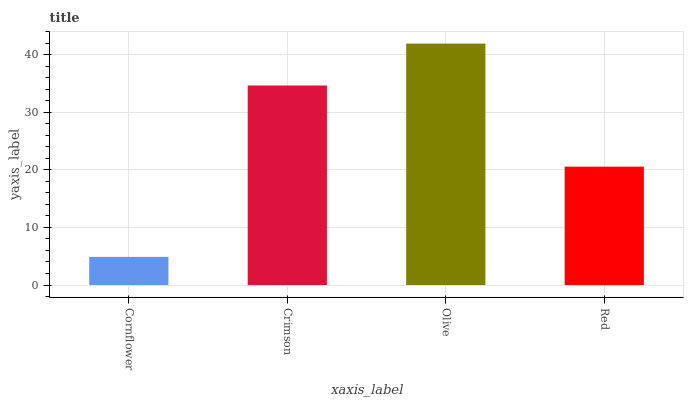Is Cornflower the minimum?
Answer yes or no. Yes. Is Olive the maximum?
Answer yes or no. Yes. Is Crimson the minimum?
Answer yes or no. No. Is Crimson the maximum?
Answer yes or no. No. Is Crimson greater than Cornflower?
Answer yes or no. Yes. Is Cornflower less than Crimson?
Answer yes or no. Yes. Is Cornflower greater than Crimson?
Answer yes or no. No. Is Crimson less than Cornflower?
Answer yes or no. No. Is Crimson the high median?
Answer yes or no. Yes. Is Red the low median?
Answer yes or no. Yes. Is Olive the high median?
Answer yes or no. No. Is Olive the low median?
Answer yes or no. No. 